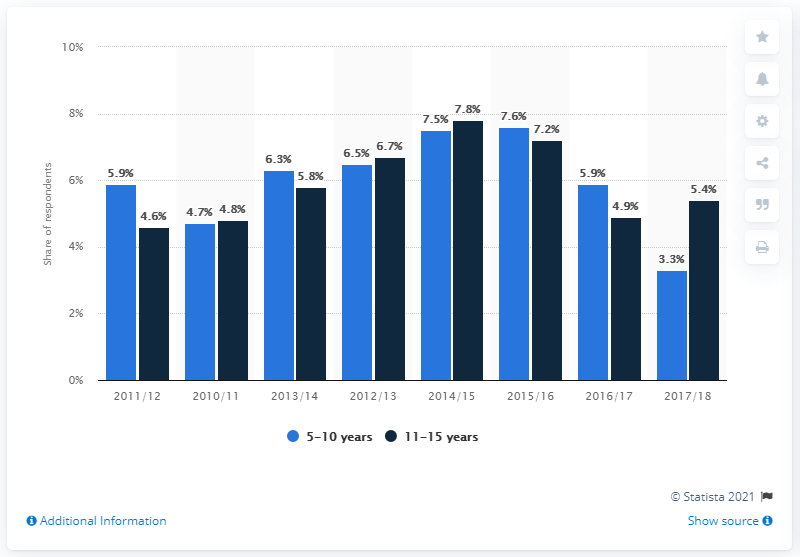Indicate a few pertinent items in this graphic. In 2017/18, 3.3% of 5-10 year olds reported that they had skated in the past year. The year with the greatest difference between age categories is 2017/2018. In the survey conducted in 2014/15, the highest percentage of respondents was observed. 